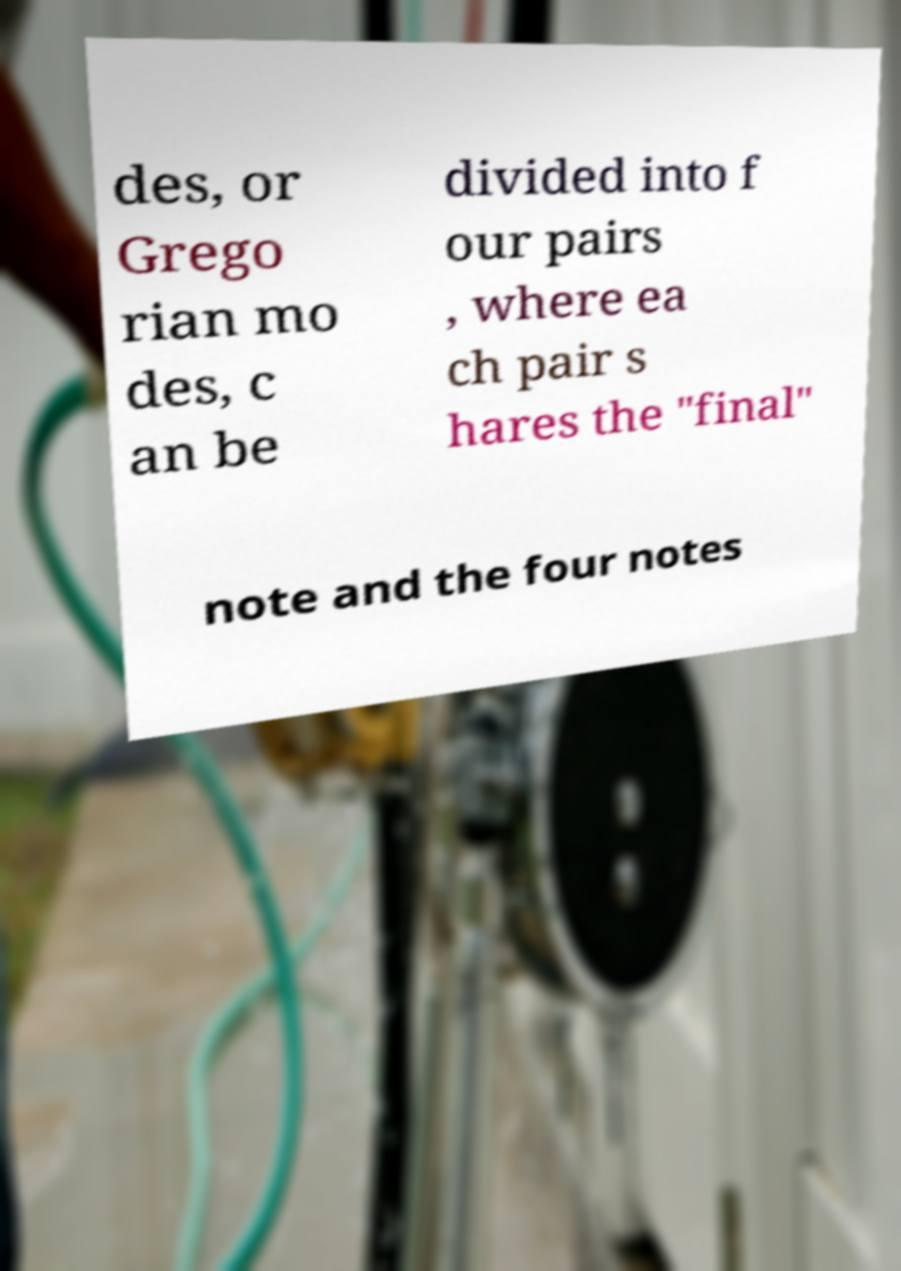Could you extract and type out the text from this image? des, or Grego rian mo des, c an be divided into f our pairs , where ea ch pair s hares the "final" note and the four notes 